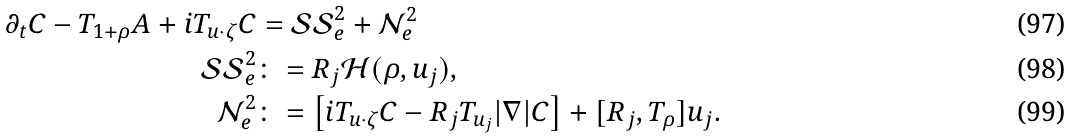Convert formula to latex. <formula><loc_0><loc_0><loc_500><loc_500>\partial _ { t } C - T _ { 1 + \rho } A + i T _ { u \cdot \zeta } C & = \mathcal { S S } ^ { 2 } _ { e } + \mathcal { N } ^ { 2 } _ { e } \\ \mathcal { S S } ^ { 2 } _ { e } & \colon = R _ { j } \mathcal { H } ( \rho , u _ { j } ) , \\ \mathcal { N } ^ { 2 } _ { e } & \colon = \left [ i T _ { u \cdot \zeta } C - R _ { j } T _ { u _ { j } } | \nabla | C \right ] + [ R _ { j } , T _ { \rho } ] u _ { j } .</formula> 